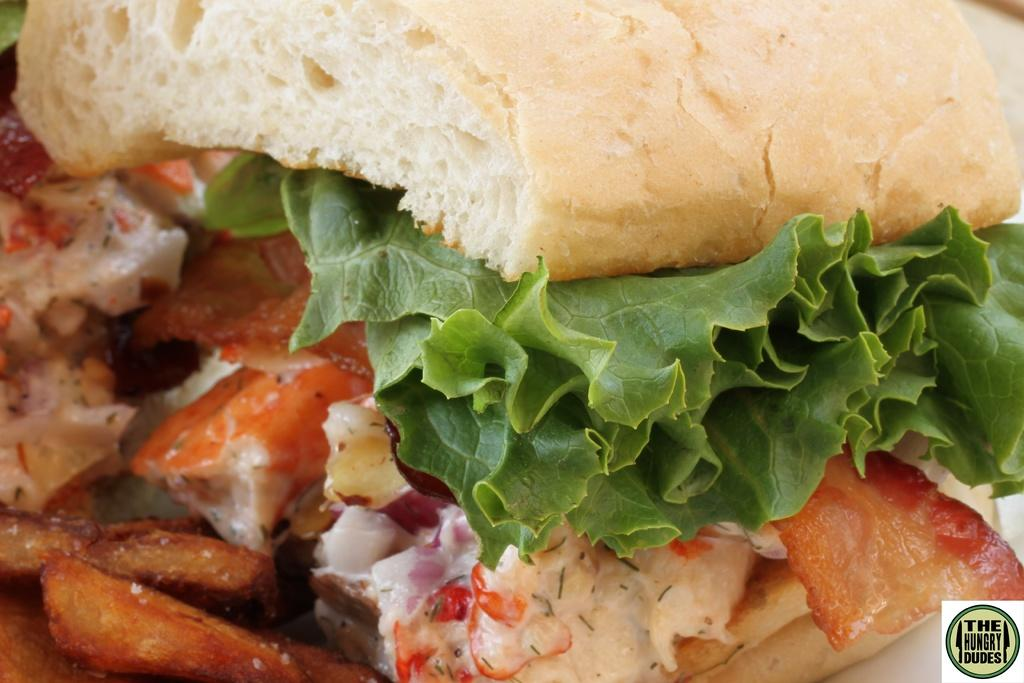What type of food is shown in the image? There is a burger in the image. What is the burger placed on? The burger is on a white color plate. What type of insurance is required for the burger in the image? There is no mention of insurance in the image, and the burger does not require any insurance. 